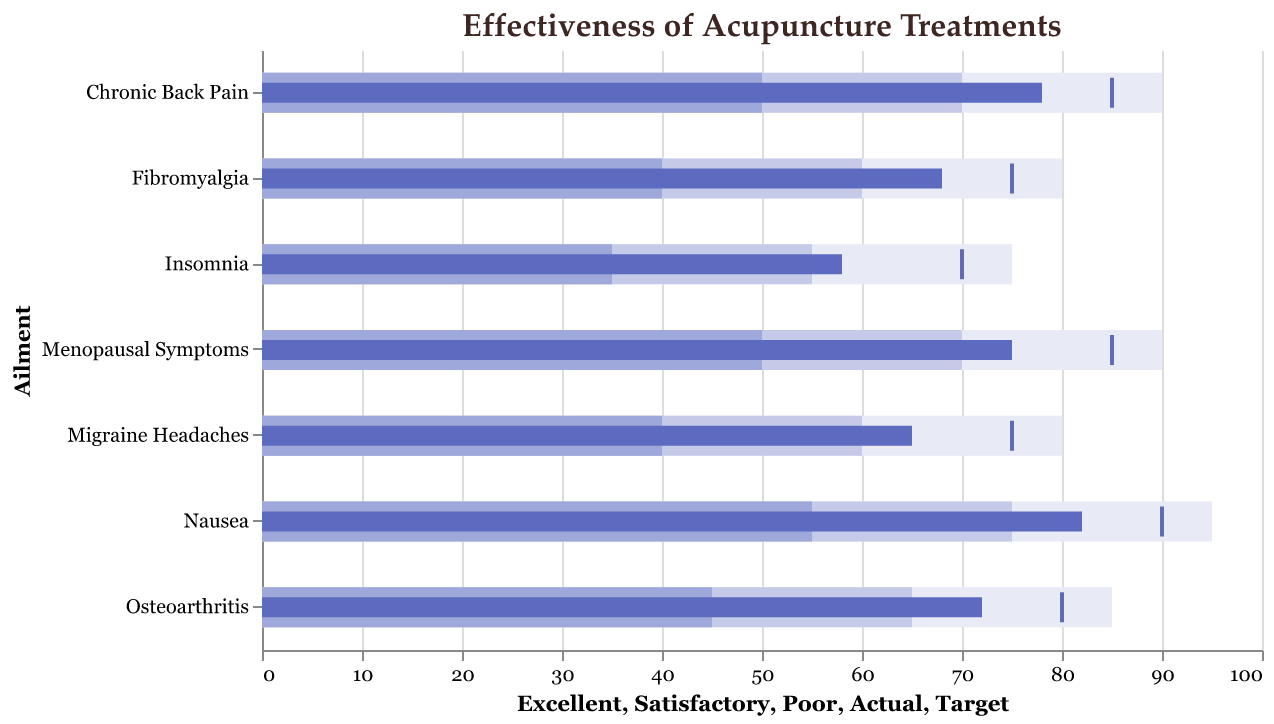What is the ailment with the highest actual effectiveness score? The ailment with the highest actual effectiveness score can be found by looking at the darkest blue bars, representing the actual effectiveness. The longest dark blue bar corresponds to "Nausea" with a score of 82.
Answer: Nausea Which ailment has the largest gap between its actual effectiveness and its target? To find the largest gap, we need to compare the actual (dark blue bar) and target (tick mark) values for each ailment. The gap for each ailment is as follows: Chronic Back Pain (85 - 78), Migraine Headaches (75 - 65), Osteoarthritis (80 - 72), Insomnia (70 - 58), Nausea (90 - 82), Fibromyalgia (75 - 68), Menopausal Symptoms (85 - 75). The largest gap is for Insomnia with a difference of 12.
Answer: Insomnia Which ailment's actual effectiveness falls below the poor threshold? Compare the actual effectiveness (dark blue bar) with the poor threshold (lightest blue bar) for each ailment. Only "Insomnia" has an actual effectiveness (58) below its poor threshold (35).
Answer: Insomnia How many ailments have their actual effectiveness scores within the satisfactory range? The satisfactory range is between the light blue and medium blue bars. Compare the actual effectiveness (dark blue bar) to see if it falls within this range for each ailment. The ailments within their satisfactory range are Migraine Headaches, Osteoarthritis, Fibromyalgia, and Menopausal Symptoms.
Answer: Four Which ailment's target effectiveness is closest to its excellent threshold? Compare the target (tick mark) with the excellent threshold (darkest blue bar) for each ailment. Chronic Back Pain has a target of 85 and an excellent threshold of 90, which is the closest gap of 5.
Answer: Chronic Back Pain What is the difference between the actual and excellent effectiveness scores for Fibromyalgia? To find the difference, subtract the actual score (68) from the excellent score (80) for Fibromyalgia. The calculation is 80 - 68 = 12.
Answer: 12 Which ailment shows both actual effectiveness and target effectiveness within the satisfactory range? Compare both the actual effectiveness (dark blue bar) and target effectiveness (tick mark) to ensure they both fall within the satisfactory range for each ailment. "Menopausal Symptoms" fits this criterion with actual effectiveness at 75 and a satisfactory range of 70-85.
Answer: Menopausal Symptoms 